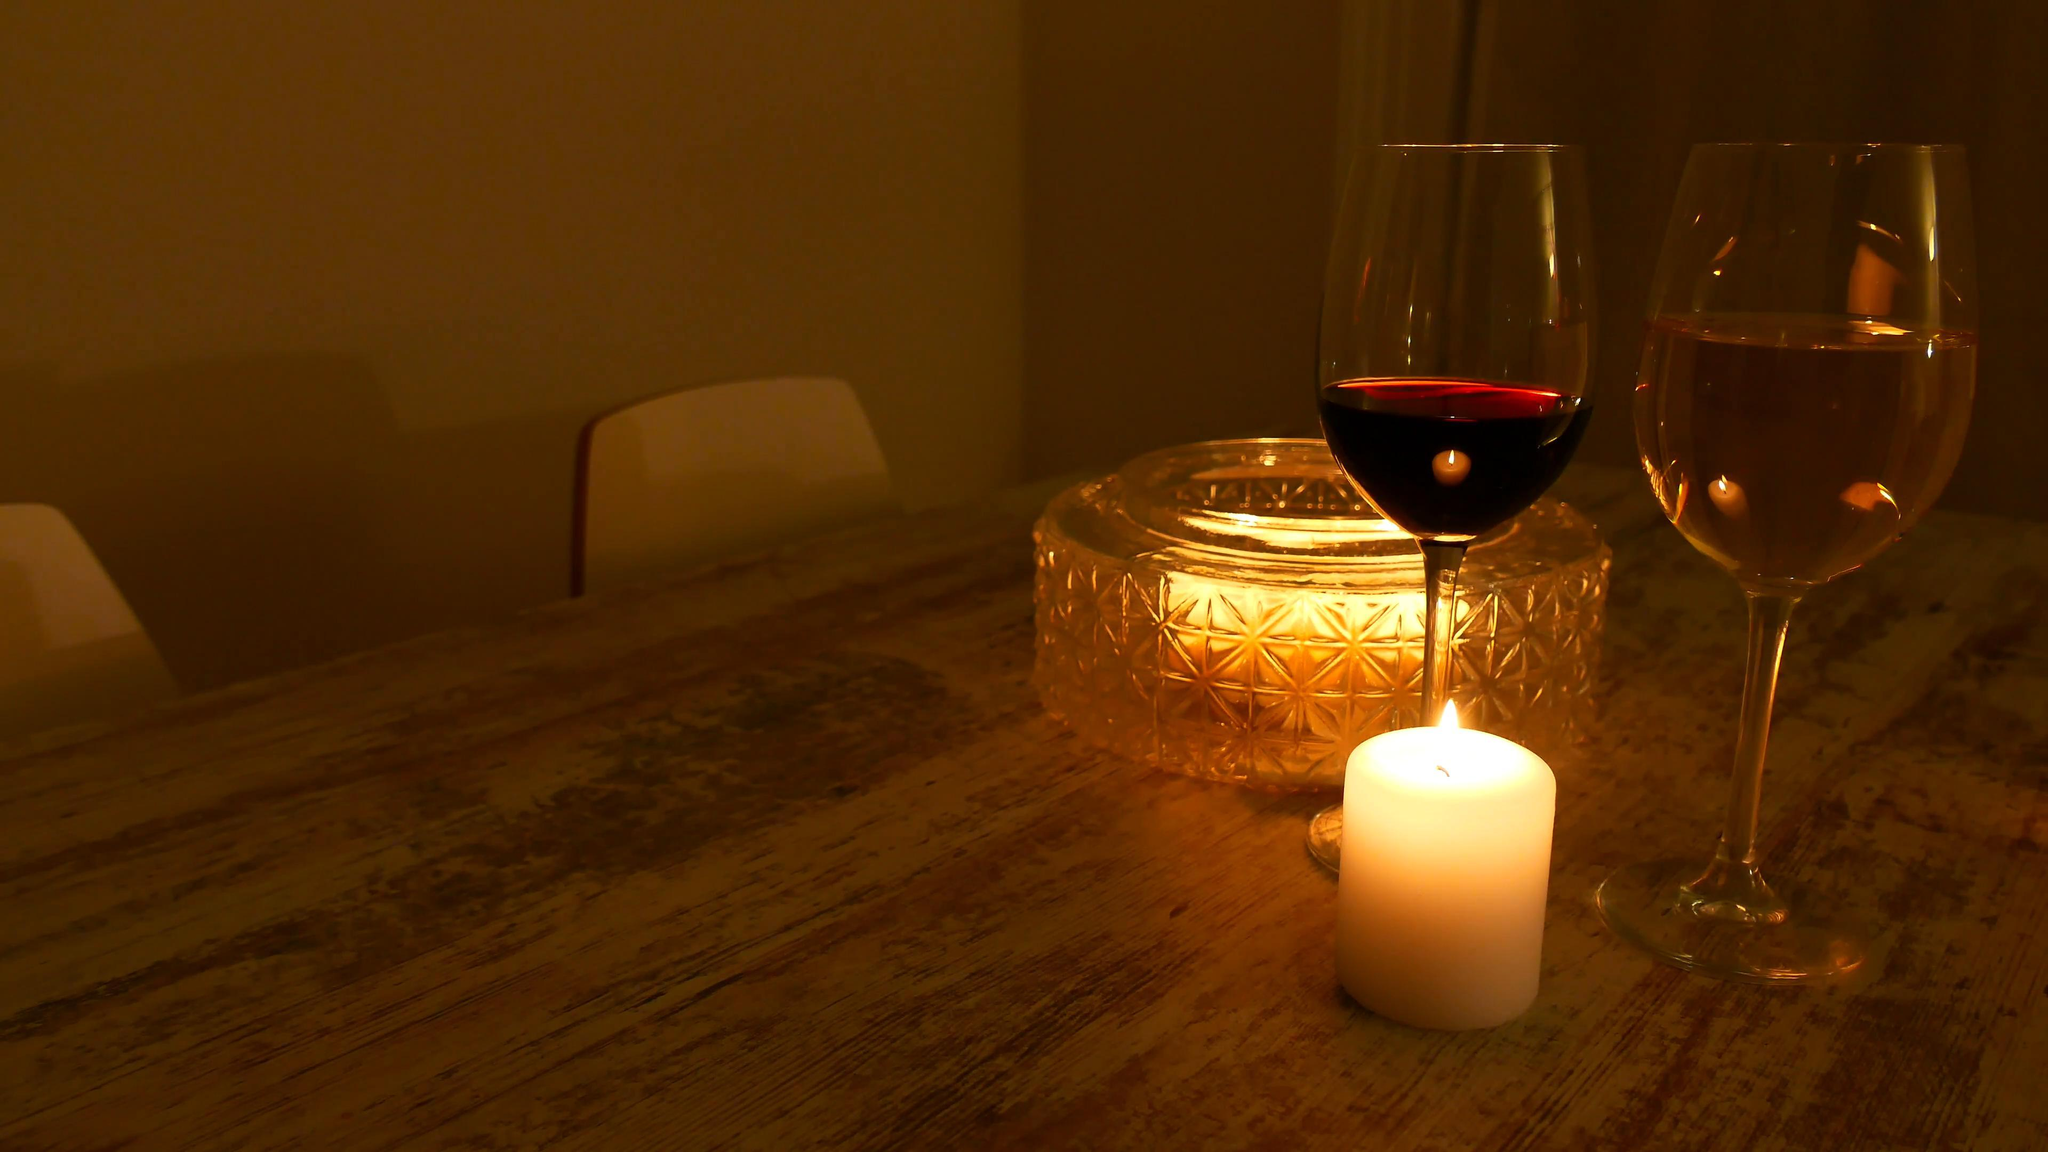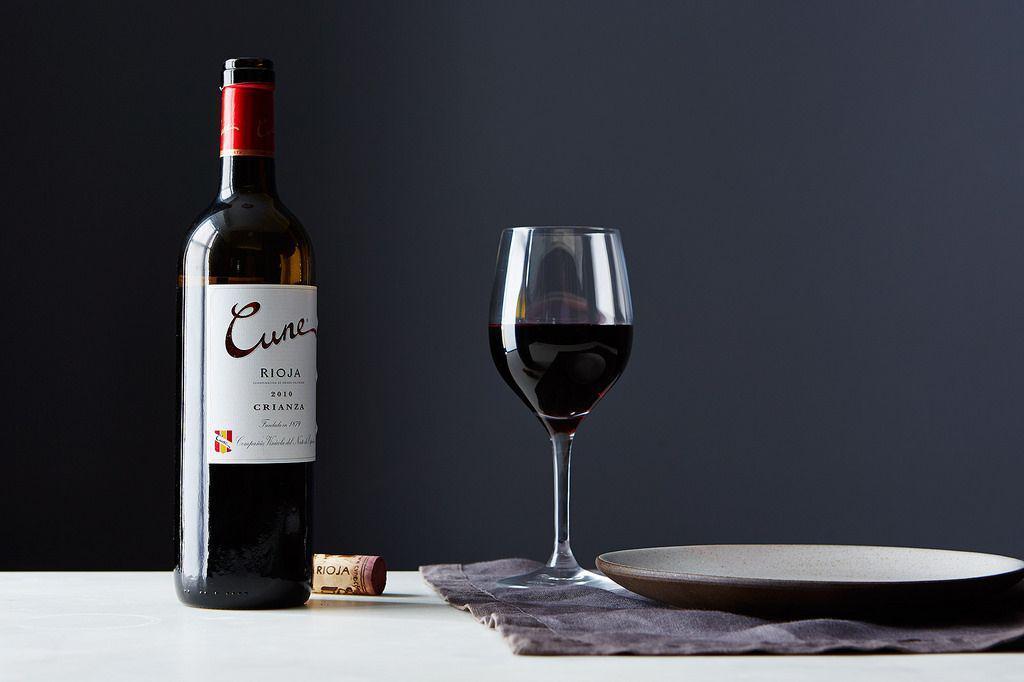The first image is the image on the left, the second image is the image on the right. Examine the images to the left and right. Is the description "There is a red bottle of wine with a red top mostly full to the left of a single stemed glass of  red wine filled to the halfway point." accurate? Answer yes or no. Yes. 